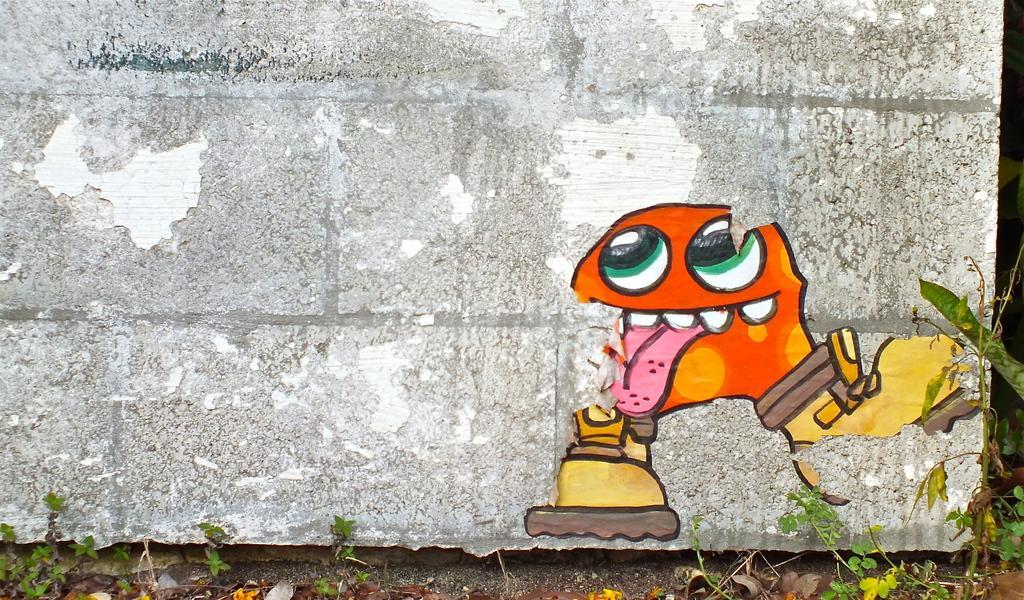Describe this image in one or two sentences. In this image we can see some painting on a wall. We can also see some plants. 